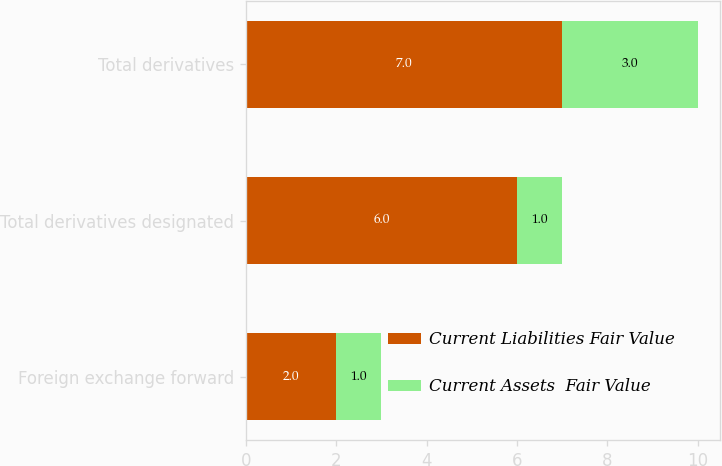Convert chart to OTSL. <chart><loc_0><loc_0><loc_500><loc_500><stacked_bar_chart><ecel><fcel>Foreign exchange forward<fcel>Total derivatives designated<fcel>Total derivatives<nl><fcel>Current Liabilities Fair Value<fcel>2<fcel>6<fcel>7<nl><fcel>Current Assets  Fair Value<fcel>1<fcel>1<fcel>3<nl></chart> 